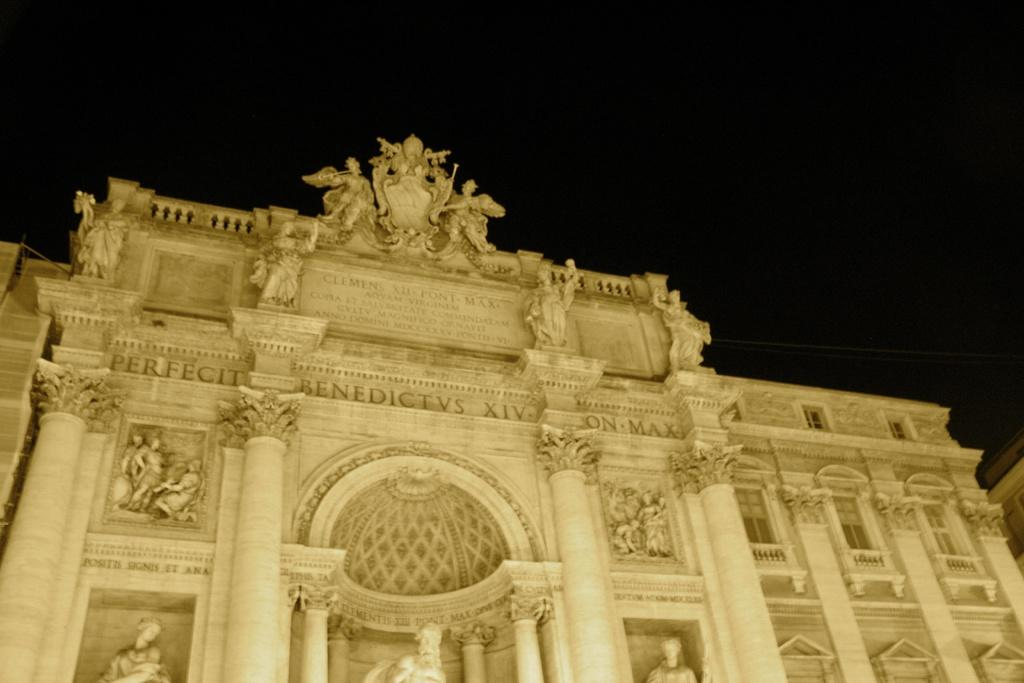What type of structure is visible in the image? There is a building in the image. What architectural features can be seen on the building? There are pillars in the image. Is there any artwork or decoration on the building? Yes, there is a statue on the building. What is the color of the background in the image? The background of the image is dark. Can you see any insects crawling on the statue in the image? There is no insect present on the statue or anywhere else in the image. Is there a stream flowing near the building in the image? There is no stream visible in the image; it only features the building, pillars, statue, and dark background. 